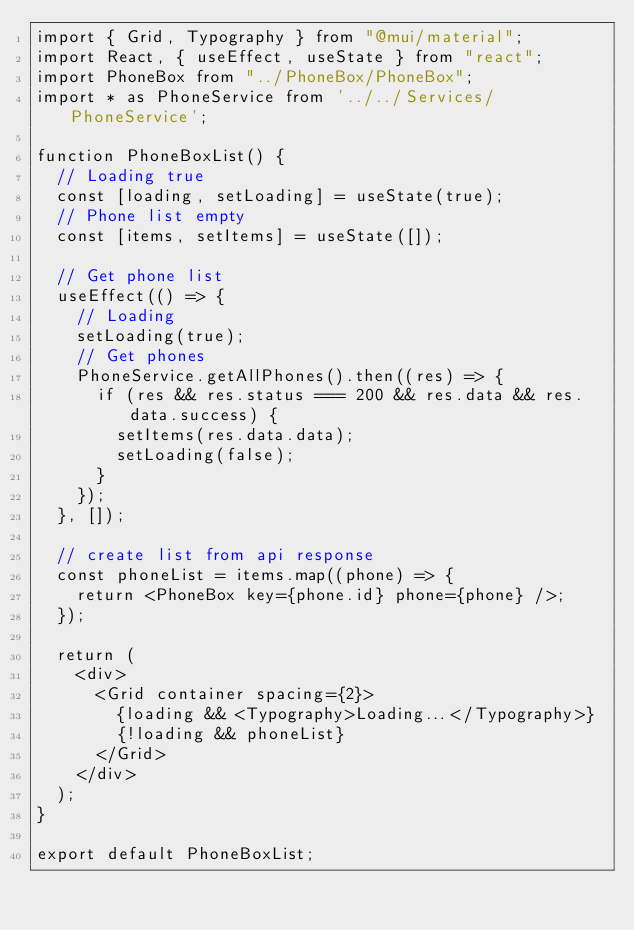<code> <loc_0><loc_0><loc_500><loc_500><_JavaScript_>import { Grid, Typography } from "@mui/material";
import React, { useEffect, useState } from "react";
import PhoneBox from "../PhoneBox/PhoneBox";
import * as PhoneService from '../../Services/PhoneService';

function PhoneBoxList() {
  // Loading true
  const [loading, setLoading] = useState(true);
  // Phone list empty
  const [items, setItems] = useState([]);

  // Get phone list
  useEffect(() => {
    // Loading
    setLoading(true);
    // Get phones
    PhoneService.getAllPhones().then((res) => {
      if (res && res.status === 200 && res.data && res.data.success) {
        setItems(res.data.data);
        setLoading(false);
      }
    });
  }, []);

  // create list from api response
  const phoneList = items.map((phone) => {
    return <PhoneBox key={phone.id} phone={phone} />;
  });

  return (
    <div>
      <Grid container spacing={2}>
        {loading && <Typography>Loading...</Typography>}
        {!loading && phoneList}
      </Grid>
    </div>
  );
}

export default PhoneBoxList;
</code> 